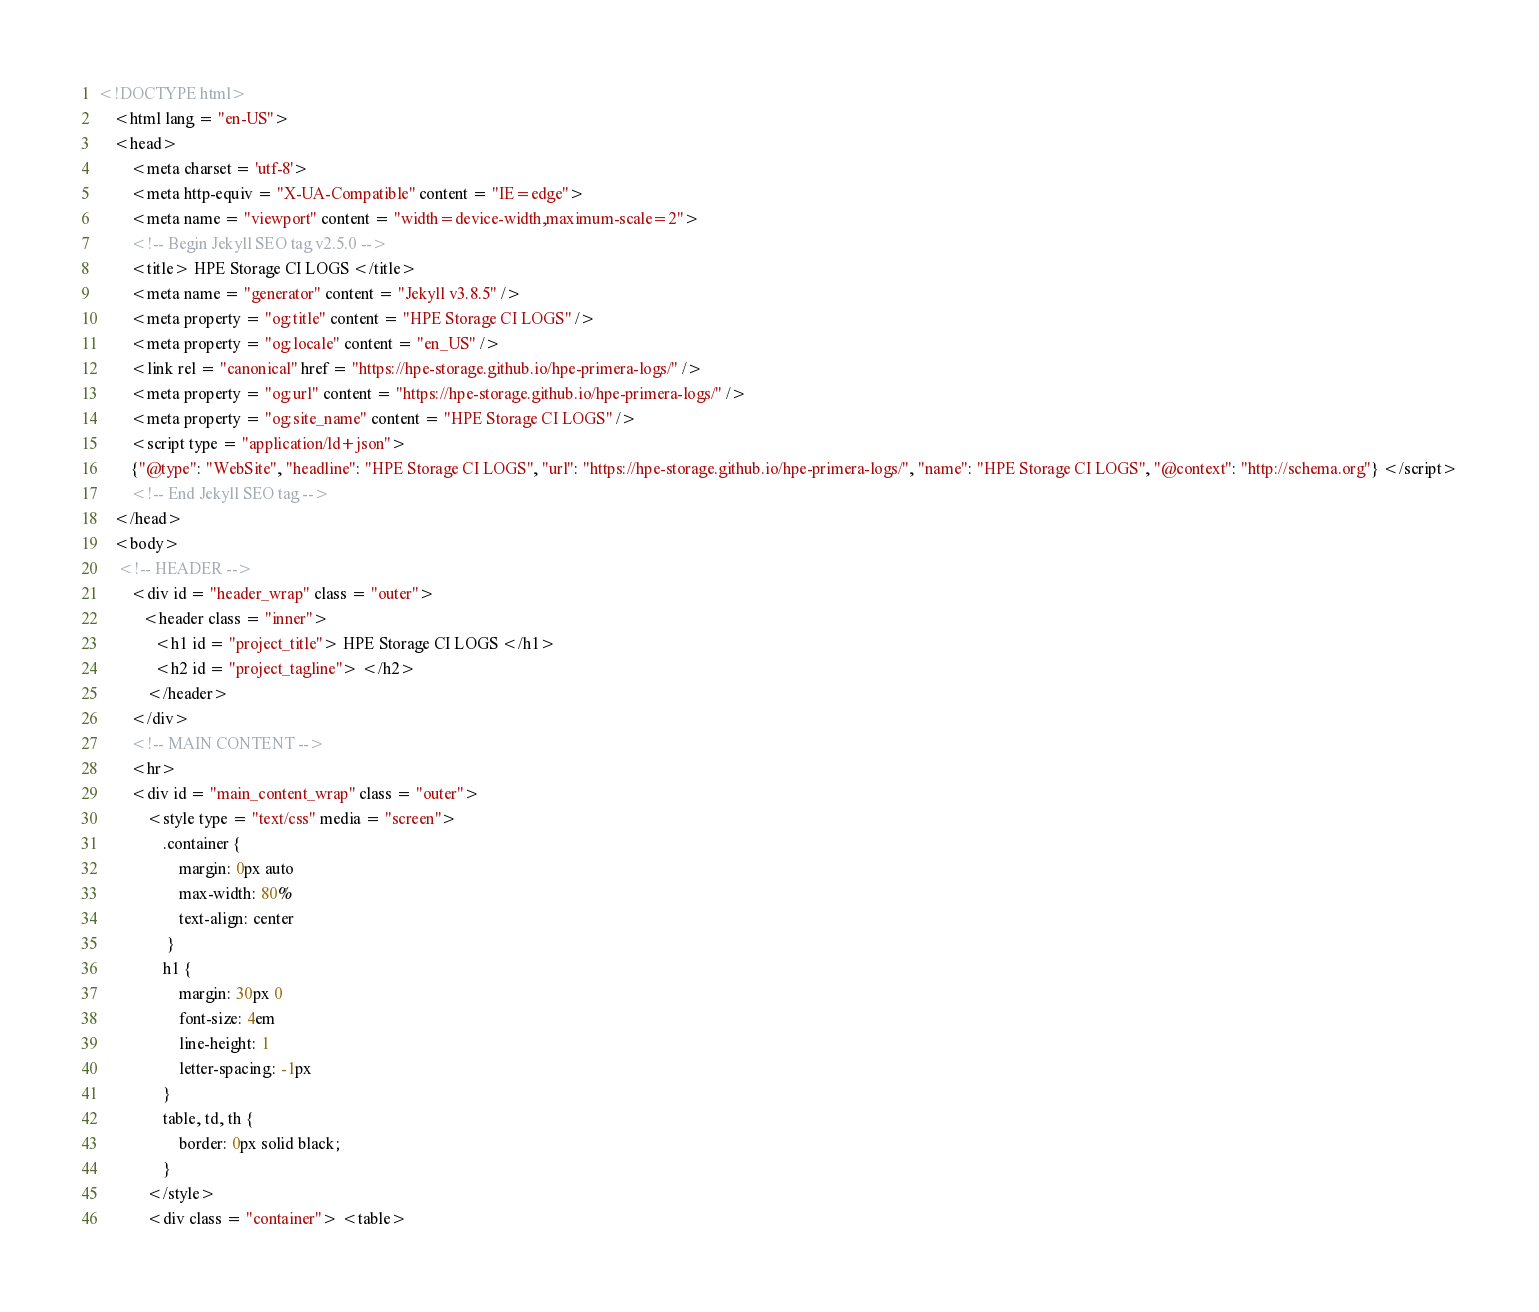Convert code to text. <code><loc_0><loc_0><loc_500><loc_500><_HTML_>
<!DOCTYPE html>
    <html lang = "en-US">
    <head>
        <meta charset = 'utf-8'>
        <meta http-equiv = "X-UA-Compatible" content = "IE=edge">
        <meta name = "viewport" content = "width=device-width,maximum-scale=2">
        <!-- Begin Jekyll SEO tag v2.5.0 -->
        <title> HPE Storage CI LOGS </title>
        <meta name = "generator" content = "Jekyll v3.8.5" />
        <meta property = "og:title" content = "HPE Storage CI LOGS" />
        <meta property = "og:locale" content = "en_US" />
        <link rel = "canonical" href = "https://hpe-storage.github.io/hpe-primera-logs/" />
        <meta property = "og:url" content = "https://hpe-storage.github.io/hpe-primera-logs/" />
        <meta property = "og:site_name" content = "HPE Storage CI LOGS" />
        <script type = "application/ld+json">
        {"@type": "WebSite", "headline": "HPE Storage CI LOGS", "url": "https://hpe-storage.github.io/hpe-primera-logs/", "name": "HPE Storage CI LOGS", "@context": "http://schema.org"} </script>
        <!-- End Jekyll SEO tag -->
    </head>
    <body>
     <!-- HEADER -->
        <div id = "header_wrap" class = "outer">
           <header class = "inner">
              <h1 id = "project_title"> HPE Storage CI LOGS </h1>
              <h2 id = "project_tagline"> </h2>
            </header>
        </div>
        <!-- MAIN CONTENT -->
        <hr>
        <div id = "main_content_wrap" class = "outer">
            <style type = "text/css" media = "screen">
                .container {
                    margin: 0px auto
                    max-width: 80%
                    text-align: center
                 }
                h1 {
                    margin: 30px 0
                    font-size: 4em
                    line-height: 1
                    letter-spacing: -1px
                }
                table, td, th {
                    border: 0px solid black;
                }
            </style>
            <div class = "container"> <table></code> 